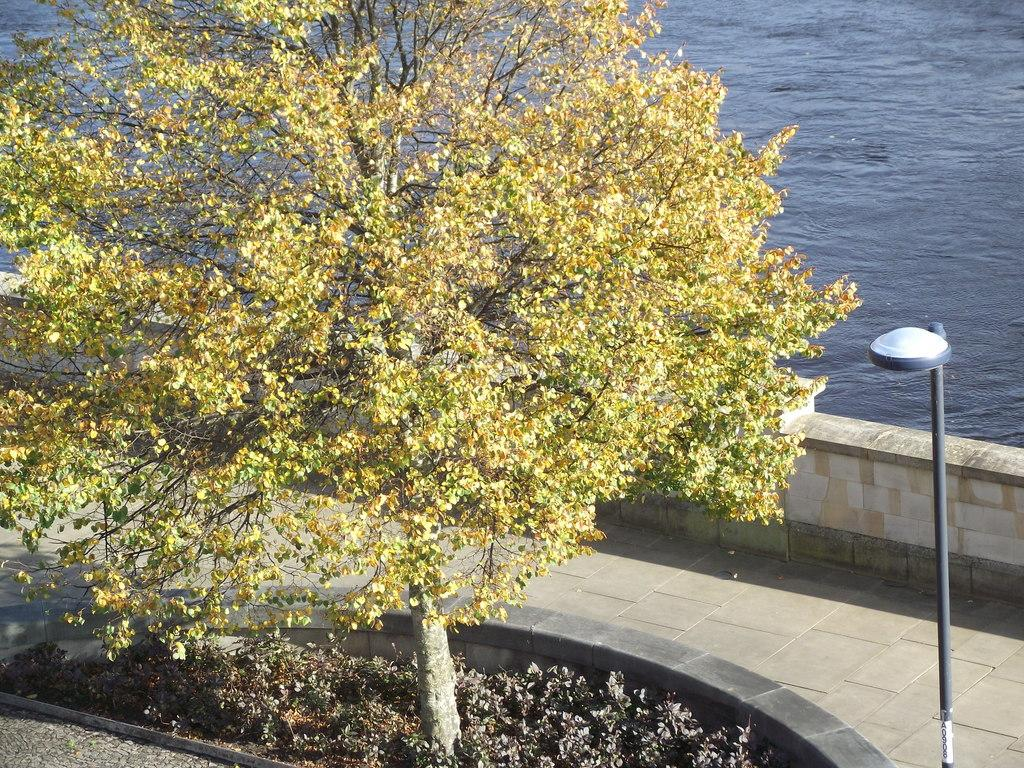What is the main subject in the center of the image? There is a tree in the center of the image. What type of vegetation is present at the bottom of the image? There are plants at the bottom of the image. What is the purpose of the object on the right side of the image? There is a street light on the right side of the image, which provides illumination. What can be seen in the background of the image? There is water visible in the background of the image. What type of structure is present in the image? There is a wall in the image. How many chains are hanging from the tree in the image? There are no chains hanging from the tree in the image. What type of bird is part of the flock flying over the water in the image? There are no birds or flocks visible in the image. 